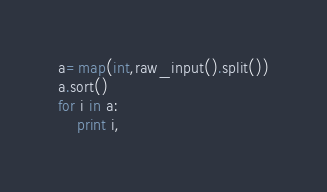Convert code to text. <code><loc_0><loc_0><loc_500><loc_500><_Python_>a=map(int,raw_input().split())
a.sort()
for i in a:
    print i,</code> 